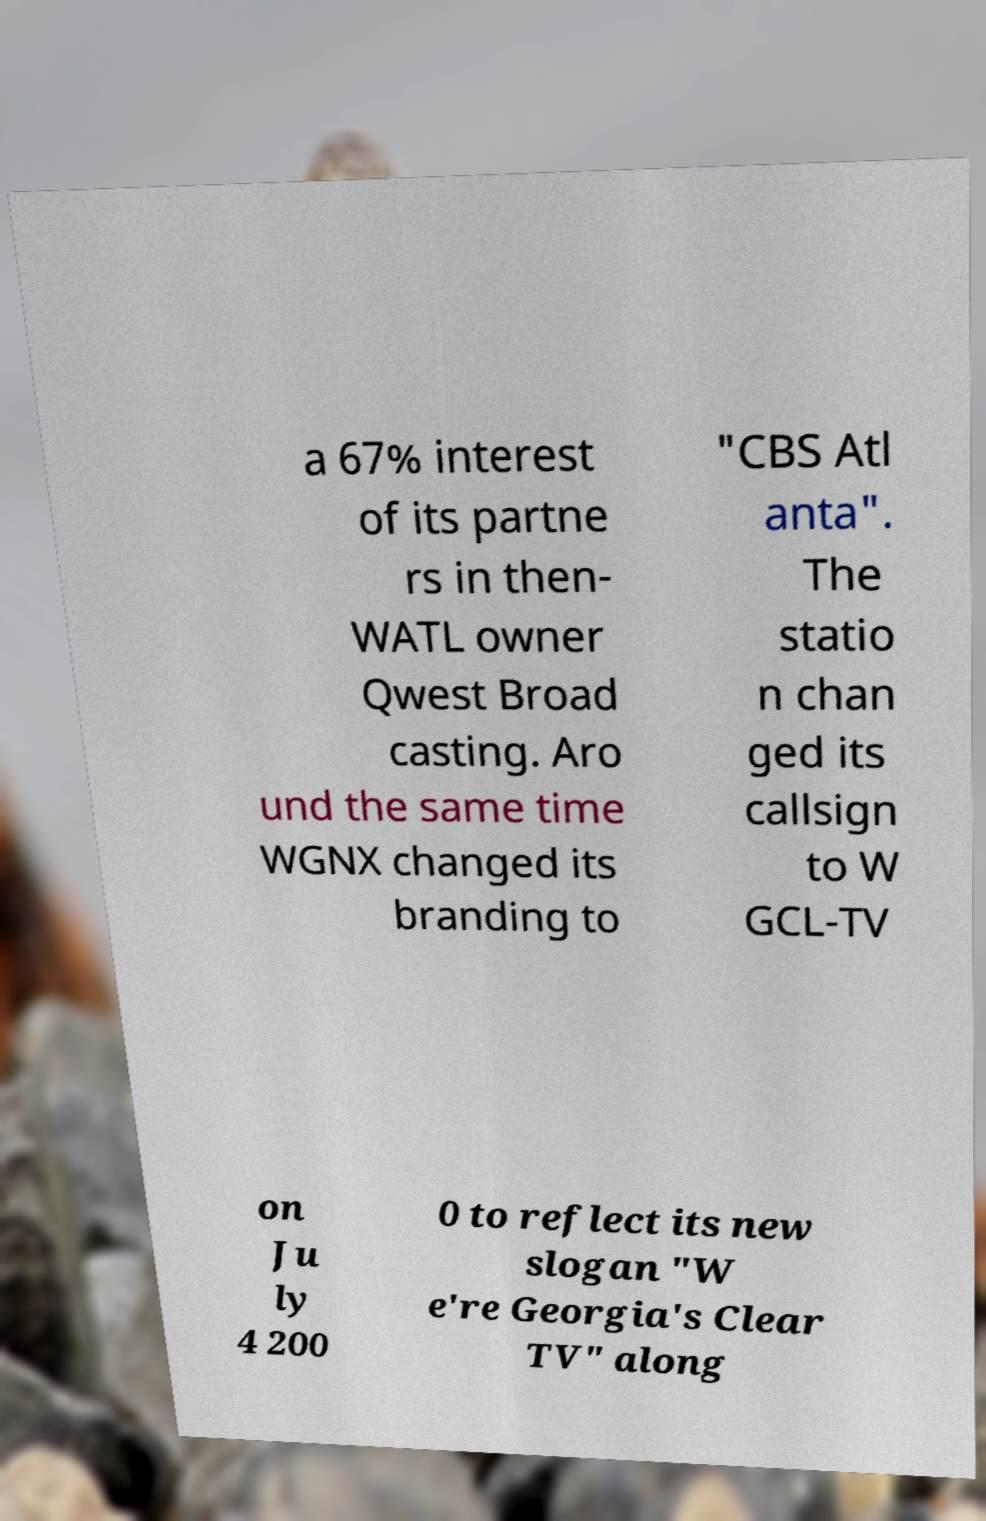Can you accurately transcribe the text from the provided image for me? a 67% interest of its partne rs in then- WATL owner Qwest Broad casting. Aro und the same time WGNX changed its branding to "CBS Atl anta". The statio n chan ged its callsign to W GCL-TV on Ju ly 4 200 0 to reflect its new slogan "W e're Georgia's Clear TV" along 